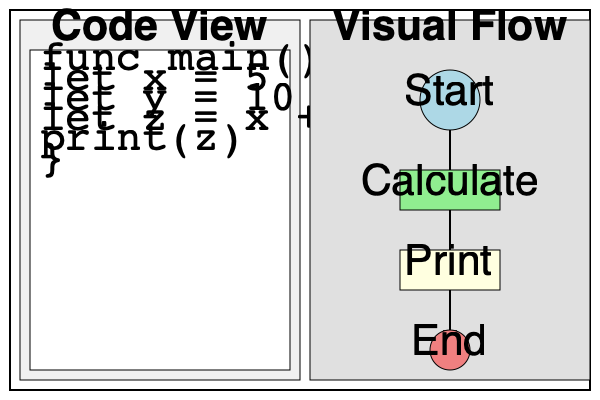As a research scientist pushing the boundaries of programming, you are tasked with designing a user interface for a new programming paradigm that combines textual code with visual flow representations. Based on the wireframe mockup provided, what key innovation does this interface introduce, and how might it enhance the programming experience for both novice and expert programmers? To answer this question, let's analyze the wireframe mockup and consider its implications:

1. Dual-panel layout: The interface is divided into two main panels - "Code View" on the left and "Visual Flow" on the right.

2. Code View:
   - Contains traditional text-based code
   - Uses a familiar syntax (similar to languages like Swift or Kotlin)
   - Provides a clear, monospaced font for easy reading

3. Visual Flow:
   - Represents the program's logic using graphical elements
   - Includes start and end points, process blocks, and flow arrows
   - Mirrors the structure of the code in the left panel

4. Real-time synchronization:
   - The visual flow appears to be automatically generated from the code
   - This suggests a bi-directional relationship between code and visual representation

5. Abstraction level:
   - The visual flow provides a higher-level view of the program's structure
   - It abstracts away some details while highlighting the overall logic

The key innovation in this interface is the seamless integration of textual code with a synchronized visual flow representation. This approach offers several potential benefits:

a) Enhanced comprehension: Programmers can see both the detailed code and the high-level structure simultaneously, aiding in understanding complex programs.

b) Improved debugging: The visual flow can help identify logical errors or unexpected program paths more quickly than text alone.

c) Accessibility for novices: New programmers can use the visual flow to grasp programming concepts more easily while still being exposed to actual code.

d) Efficiency for experts: Experienced programmers can quickly navigate and understand large codebases by referencing the visual flow.

e) Collaborative development: The dual representation can facilitate communication between team members with different levels of expertise.

f) Educational tool: This interface could be particularly useful in teaching programming, as it bridges the gap between conceptual understanding and code implementation.

g) Paradigm flexibility: The system appears adaptable to various programming paradigms, potentially supporting both imperative and functional styles.
Answer: Synchronized textual-visual programming interface 